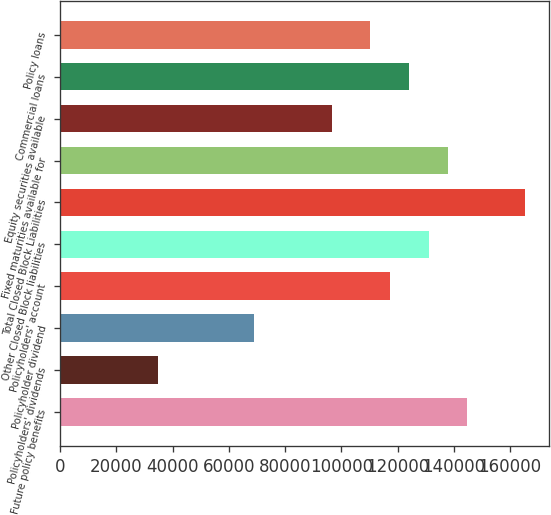Convert chart. <chart><loc_0><loc_0><loc_500><loc_500><bar_chart><fcel>Future policy benefits<fcel>Policyholders' dividends<fcel>Policyholder dividend<fcel>Policyholders' account<fcel>Other Closed Block liabilities<fcel>Total Closed Block Liabilities<fcel>Fixed maturities available for<fcel>Equity securities available<fcel>Commercial loans<fcel>Policy loans<nl><fcel>144739<fcel>34679.5<fcel>69073<fcel>117224<fcel>130981<fcel>165375<fcel>137860<fcel>96587.8<fcel>124103<fcel>110345<nl></chart> 